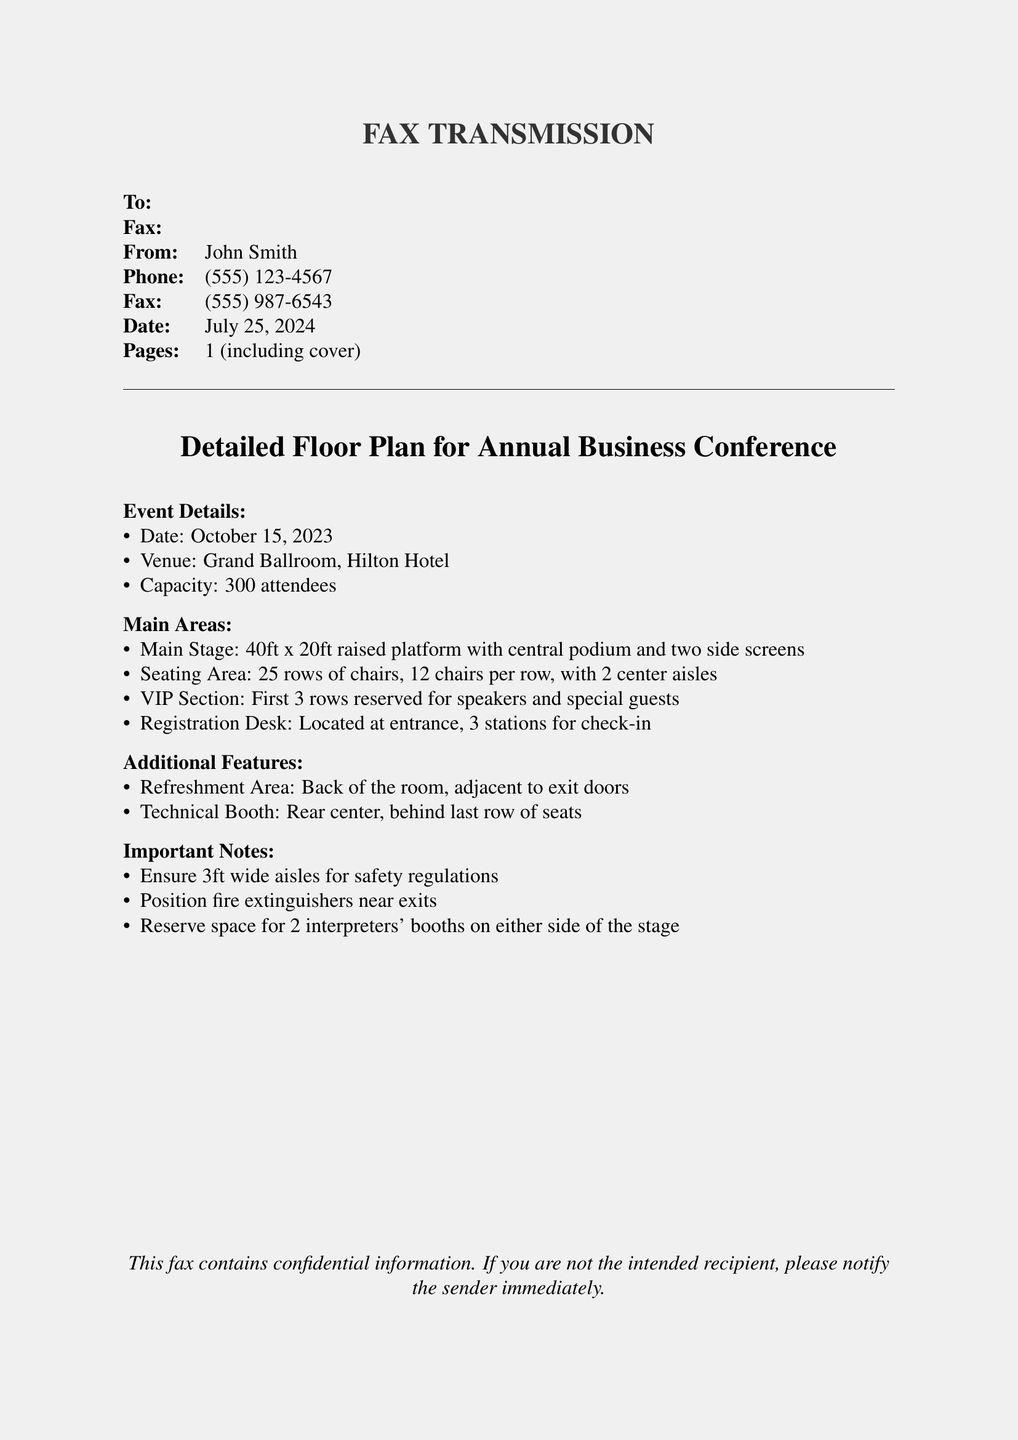what is the date of the event? The date of the event is specified in the document under "Event Details."
Answer: October 15, 2023 what is the venue of the conference? The venue is mentioned in the "Event Details" section.
Answer: Grand Ballroom, Hilton Hotel how many seats are in each row? The seating arrangement describes the number of chairs per row.
Answer: 12 chairs how many rows of chairs are there? The total number of rows is stated in the seating section of the document.
Answer: 25 rows what are the dimensions of the main stage? The size of the main stage is detailed in the "Main Areas" section.
Answer: 40ft x 20ft what type of area is located at the back of the room? The document specifies the nature of the area at the back in "Additional Features."
Answer: Refreshment Area how many check-in stations are at the registration desk? The document mentions the number of check-in stations in the "Main Areas" section.
Answer: 3 stations how wide should the aisles be? The width requirement for safety regulations is mentioned in "Important Notes."
Answer: 3ft wide how many interpreters' booths should be reserved? The number of interpreters' booths required is provided in the "Important Notes."
Answer: 2 interpreters' booths 